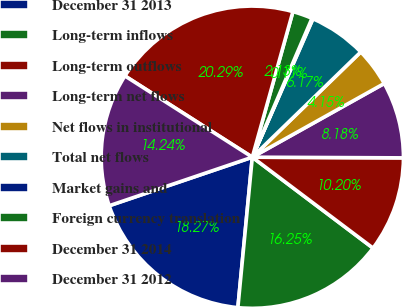<chart> <loc_0><loc_0><loc_500><loc_500><pie_chart><fcel>December 31 2013<fcel>Long-term inflows<fcel>Long-term outflows<fcel>Long-term net flows<fcel>Net flows in institutional<fcel>Total net flows<fcel>Market gains and<fcel>Foreign currency translation<fcel>December 31 2014<fcel>December 31 2012<nl><fcel>18.27%<fcel>16.25%<fcel>10.2%<fcel>8.18%<fcel>4.15%<fcel>6.17%<fcel>0.11%<fcel>2.13%<fcel>20.29%<fcel>14.24%<nl></chart> 